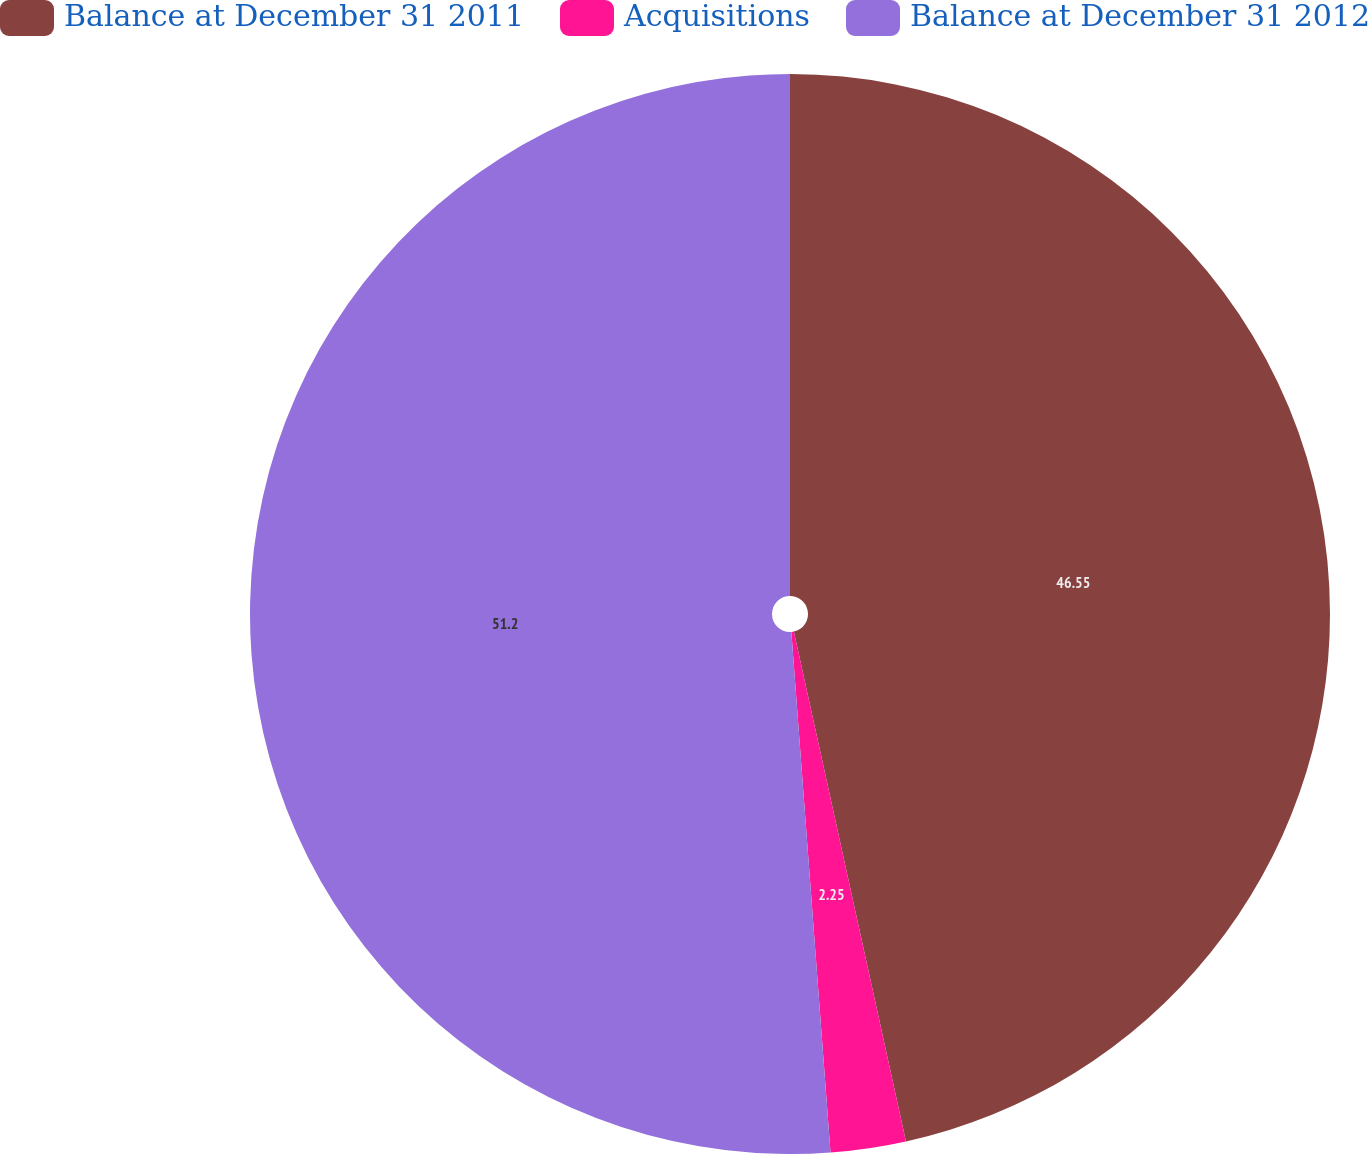Convert chart to OTSL. <chart><loc_0><loc_0><loc_500><loc_500><pie_chart><fcel>Balance at December 31 2011<fcel>Acquisitions<fcel>Balance at December 31 2012<nl><fcel>46.55%<fcel>2.25%<fcel>51.19%<nl></chart> 